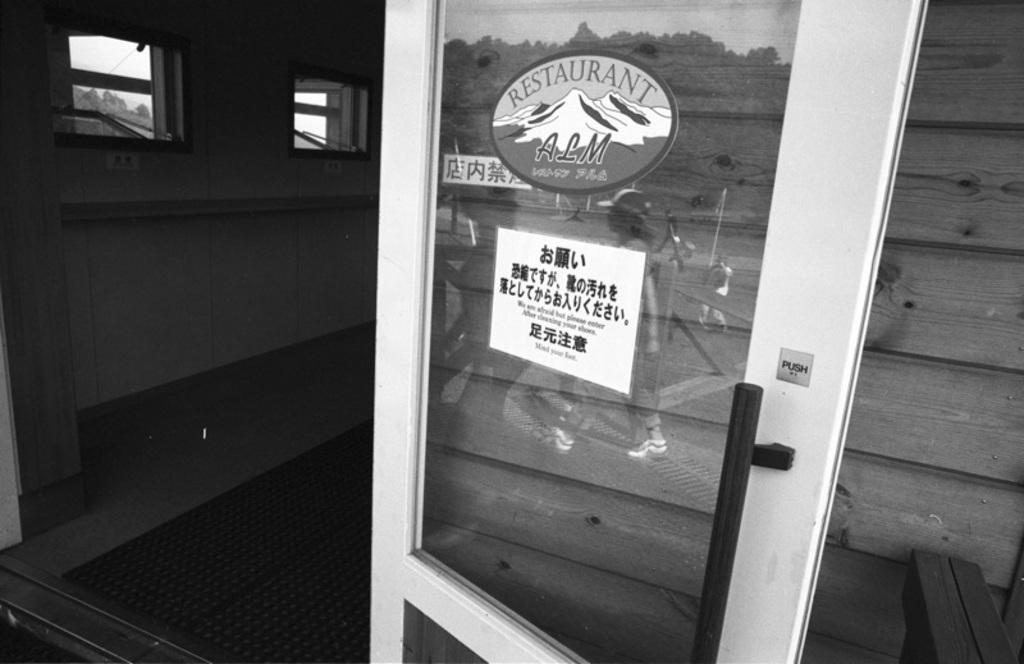Please provide a concise description of this image. In this picture, we see glass door and posters are pasted on it. Beside that, we see a wall and windows from which we can see trees. Behind the door, we see a wooden wall. This is a black and white picture. 